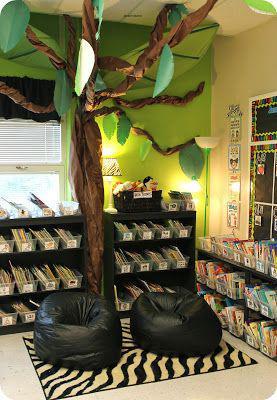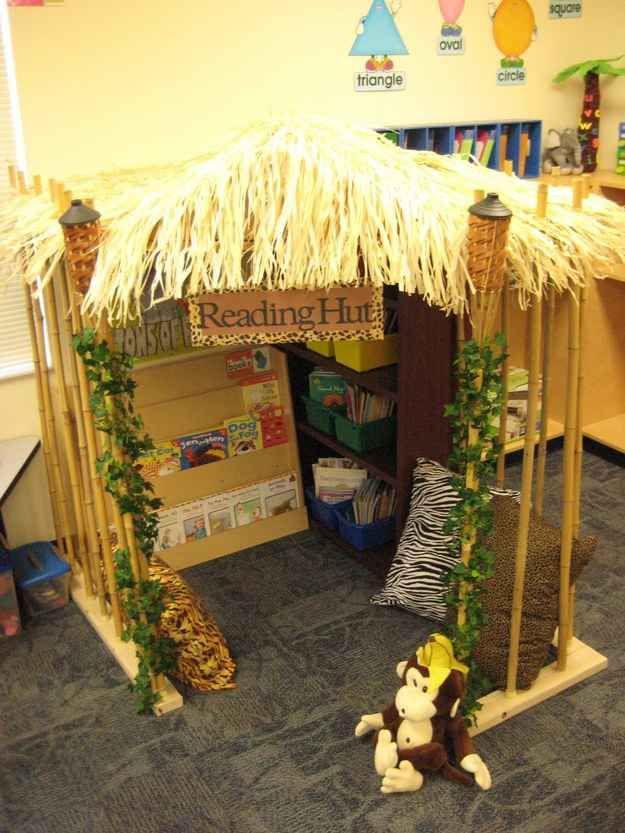The first image is the image on the left, the second image is the image on the right. Examine the images to the left and right. Is the description "The left image features books arranged on tiered shelves of a wooden pyramid-shaped structure in a library with a wood floor." accurate? Answer yes or no. No. 